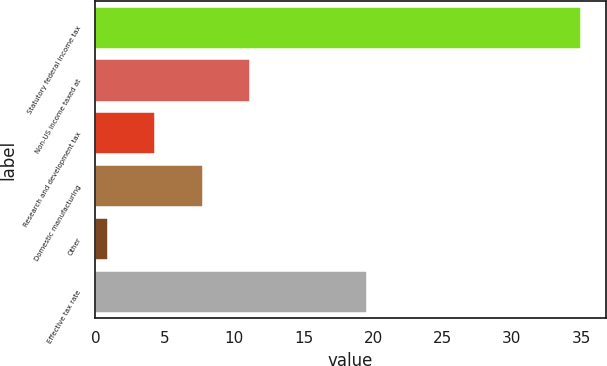Convert chart to OTSL. <chart><loc_0><loc_0><loc_500><loc_500><bar_chart><fcel>Statutory federal income tax<fcel>Non-US income taxed at<fcel>Research and development tax<fcel>Domestic manufacturing<fcel>Other<fcel>Effective tax rate<nl><fcel>35<fcel>11.13<fcel>4.31<fcel>7.72<fcel>0.9<fcel>19.6<nl></chart> 